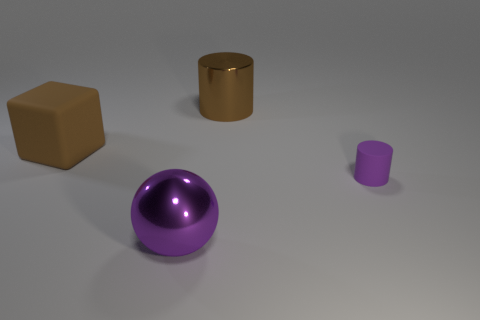Add 2 tiny purple spheres. How many objects exist? 6 Subtract all spheres. How many objects are left? 3 Add 1 metallic cylinders. How many metallic cylinders exist? 2 Subtract 0 blue cylinders. How many objects are left? 4 Subtract all matte cylinders. Subtract all small purple cylinders. How many objects are left? 2 Add 4 objects. How many objects are left? 8 